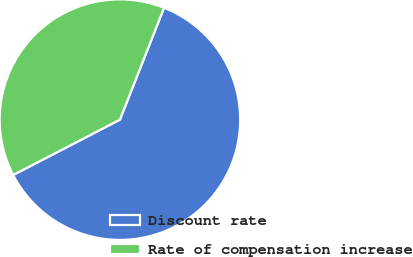<chart> <loc_0><loc_0><loc_500><loc_500><pie_chart><fcel>Discount rate<fcel>Rate of compensation increase<nl><fcel>61.41%<fcel>38.59%<nl></chart> 